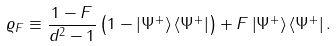Convert formula to latex. <formula><loc_0><loc_0><loc_500><loc_500>\varrho _ { F } \equiv \frac { 1 - F } { d ^ { 2 } - 1 } \left ( { 1 } - \left | \Psi ^ { + } \right \rangle \left \langle \Psi ^ { + } \right | \right ) + F \left | \Psi ^ { + } \right \rangle \left \langle \Psi ^ { + } \right | .</formula> 